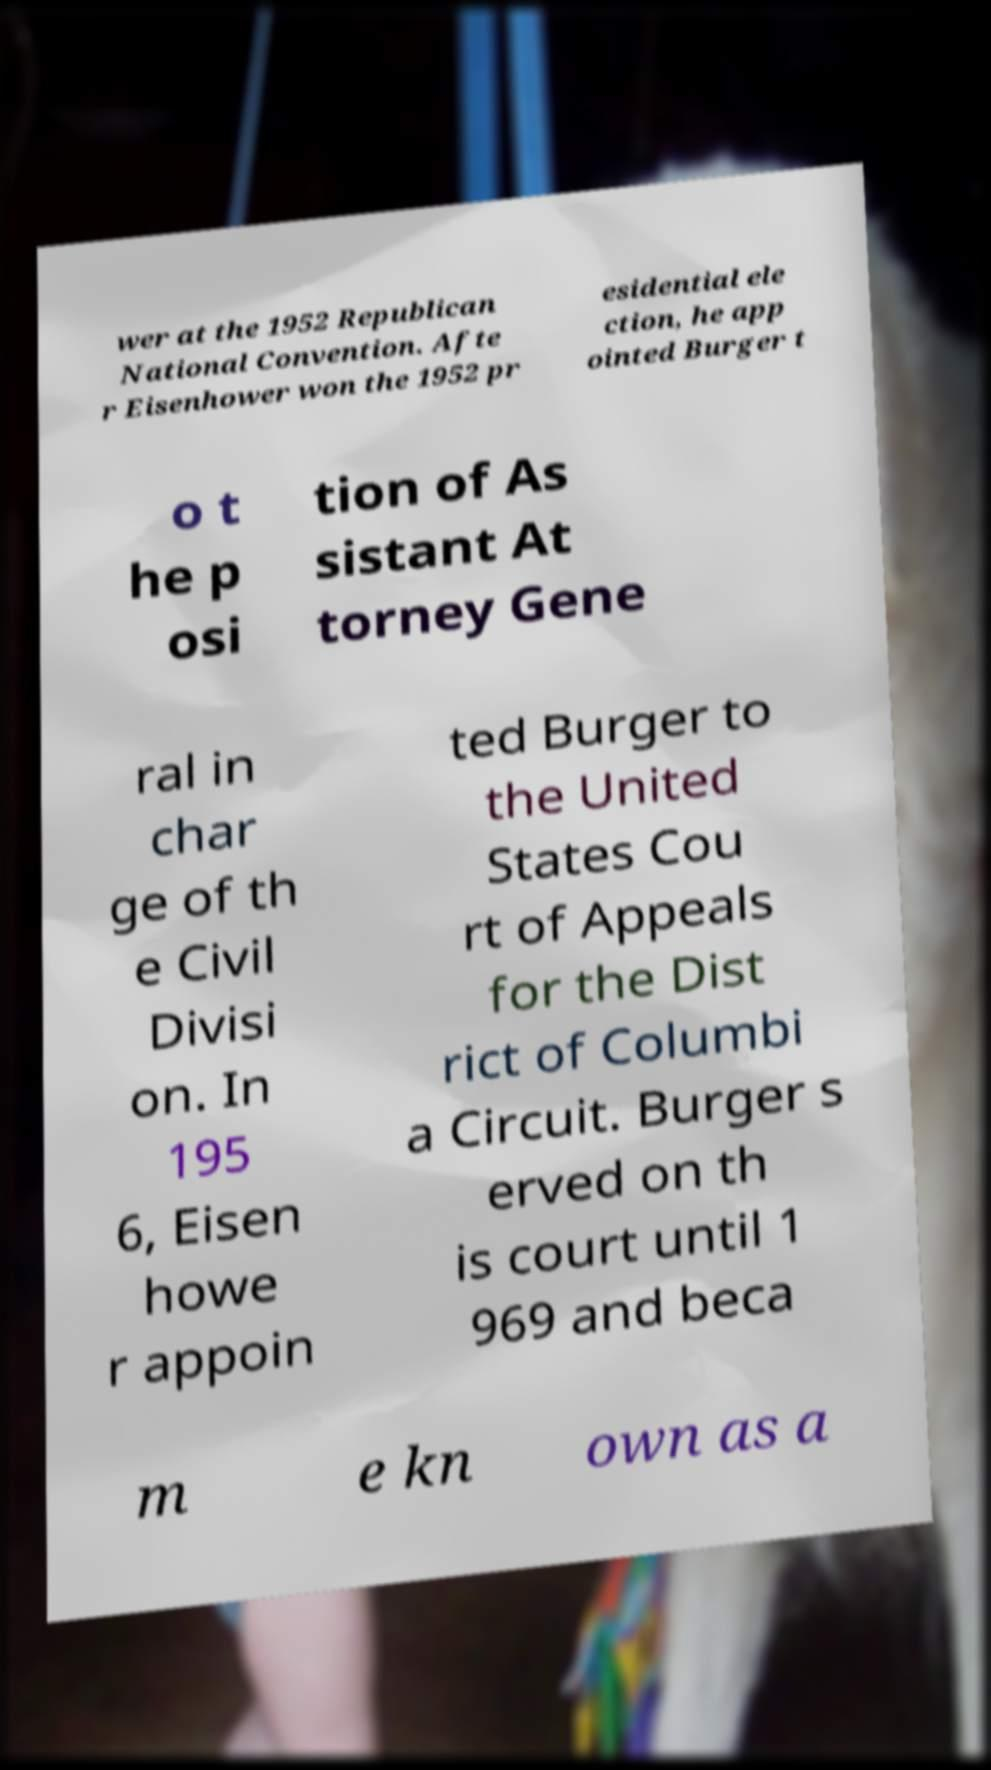Could you assist in decoding the text presented in this image and type it out clearly? wer at the 1952 Republican National Convention. Afte r Eisenhower won the 1952 pr esidential ele ction, he app ointed Burger t o t he p osi tion of As sistant At torney Gene ral in char ge of th e Civil Divisi on. In 195 6, Eisen howe r appoin ted Burger to the United States Cou rt of Appeals for the Dist rict of Columbi a Circuit. Burger s erved on th is court until 1 969 and beca m e kn own as a 